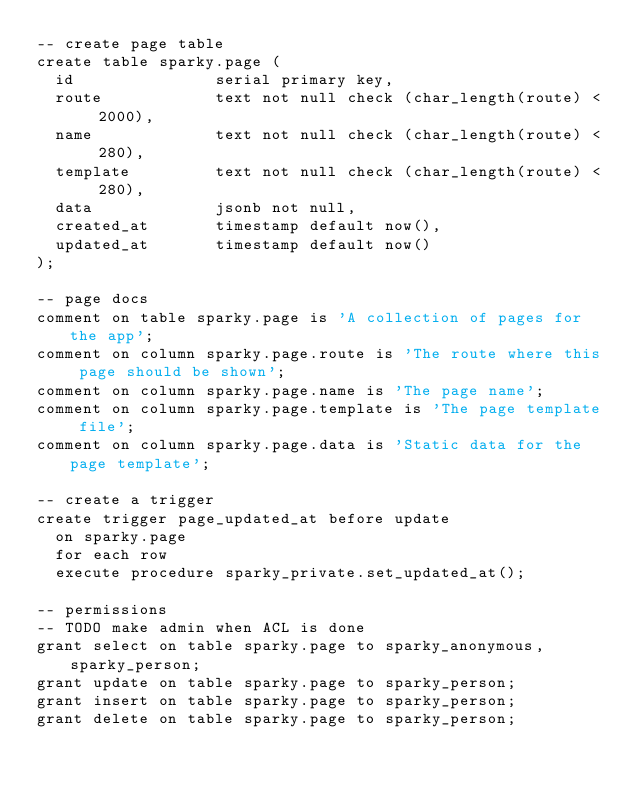<code> <loc_0><loc_0><loc_500><loc_500><_SQL_>-- create page table
create table sparky.page (
  id               serial primary key,
  route            text not null check (char_length(route) < 2000),
  name             text not null check (char_length(route) < 280),
  template         text not null check (char_length(route) < 280),
  data             jsonb not null,
  created_at       timestamp default now(),
  updated_at       timestamp default now()
);

-- page docs
comment on table sparky.page is 'A collection of pages for the app';
comment on column sparky.page.route is 'The route where this page should be shown';
comment on column sparky.page.name is 'The page name';
comment on column sparky.page.template is 'The page template file';
comment on column sparky.page.data is 'Static data for the page template';

-- create a trigger
create trigger page_updated_at before update
  on sparky.page
  for each row
  execute procedure sparky_private.set_updated_at();

-- permissions
-- TODO make admin when ACL is done
grant select on table sparky.page to sparky_anonymous, sparky_person;
grant update on table sparky.page to sparky_person;
grant insert on table sparky.page to sparky_person;
grant delete on table sparky.page to sparky_person;
</code> 